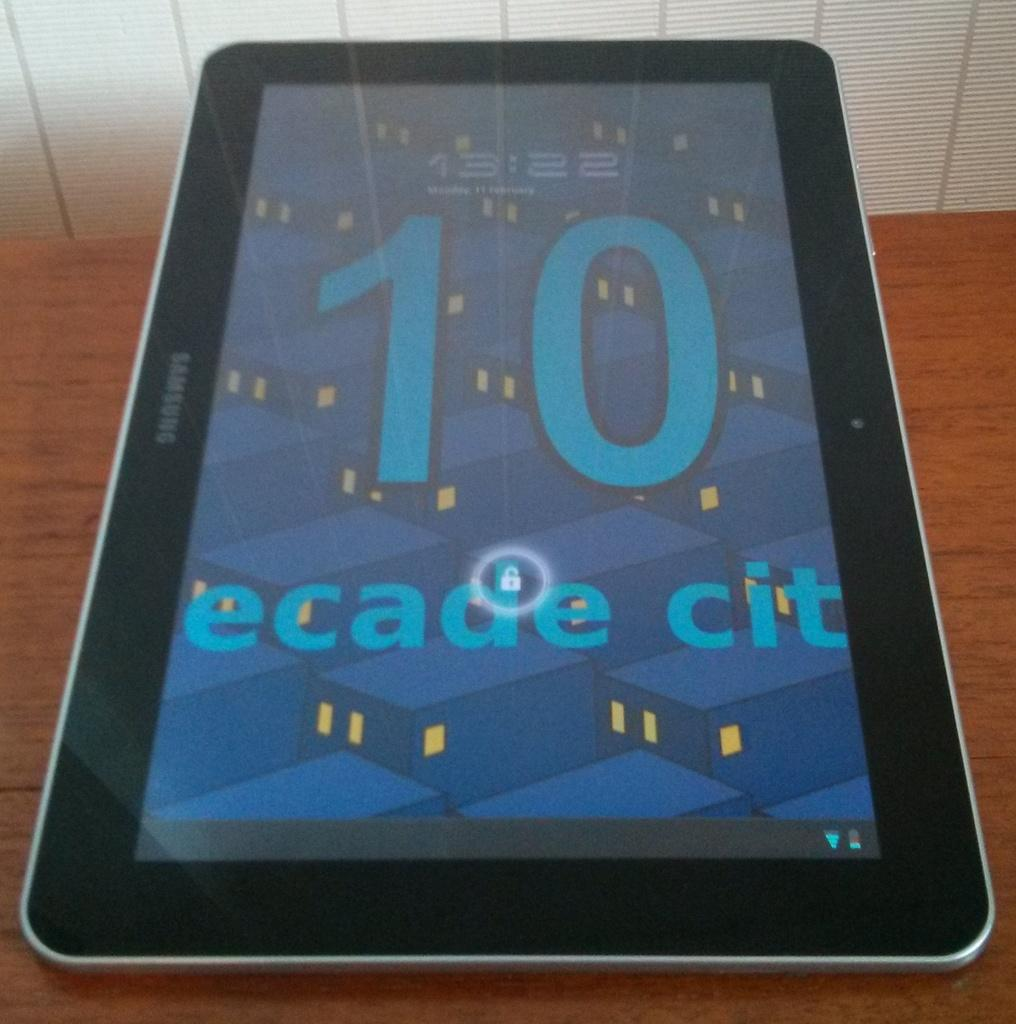What object is present in the image with a screen? There is a tab in the image with a screen. On what surface is the tab placed? The tab is placed on a wooden table. What information can be seen on the screen of the tab? The screen of the tab displays time and some text. What type of society is depicted in the image? There is no society depicted in the image; it features a tab placed on a wooden table with a screen displaying time and some text. 